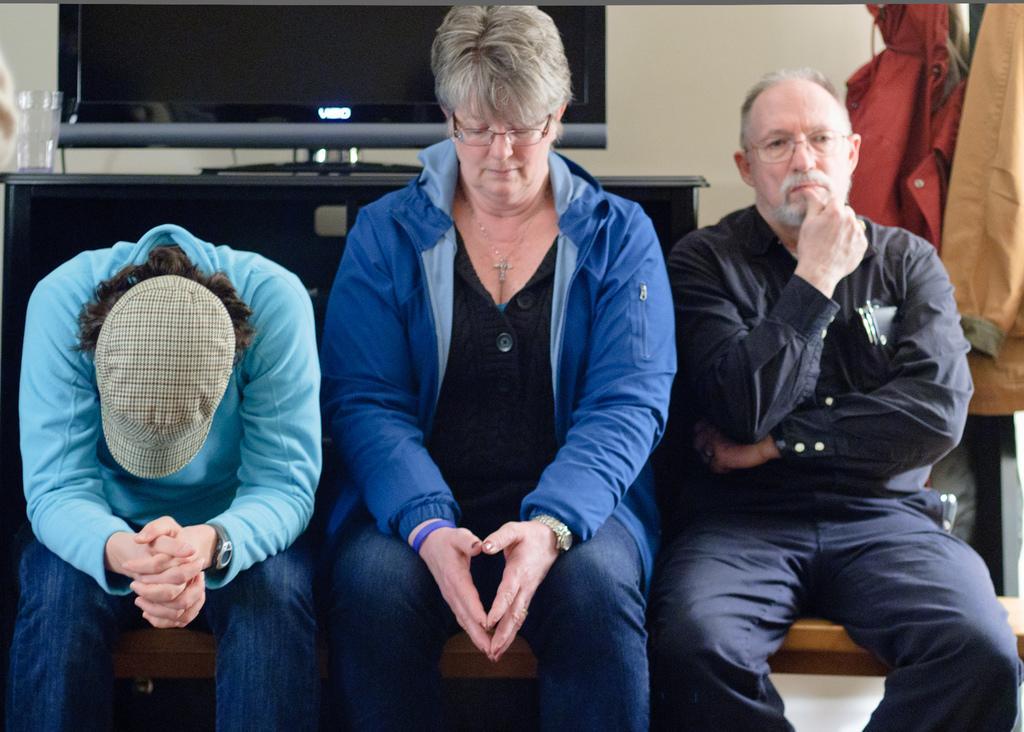Can you describe this image briefly? In this image I can see 3 people sitting. The person on the left is wearing a cap. There is a glass and a television at the back. There are coats hanging on the right. 